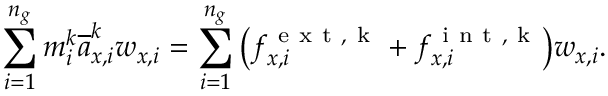Convert formula to latex. <formula><loc_0><loc_0><loc_500><loc_500>\sum _ { i = 1 } ^ { n _ { g } } m _ { i } ^ { k } \overline { a } _ { x , i } ^ { k } w _ { x , i } = \sum _ { i = 1 } ^ { n _ { g } } \left ( f _ { x , i } ^ { e x t , k } + f _ { x , i } ^ { i n t , k } \right ) w _ { x , i } .</formula> 